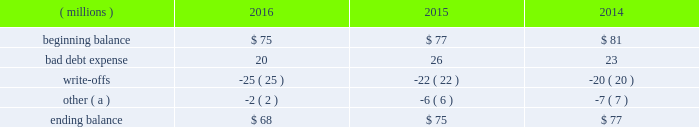Cash and cash equivalents cash equivalents include highly-liquid investments with a maturity of three months or less when purchased .
Accounts receivable and allowance for doubtful accounts accounts receivable are carried at the invoiced amounts , less an allowance for doubtful accounts , and generally do not bear interest .
The company estimates the balance of allowance for doubtful accounts by analyzing accounts receivable balances by age and applying historical write-off and collection trend rates .
The company 2019s estimates include separately providing for customer receivables based on specific circumstances and credit conditions , and when it is deemed probable that the balance is uncollectible .
Account balances are charged off against the allowance when it is determined the receivable will not be recovered .
The company 2019s allowance for doubtful accounts balance also includes an allowance for the expected return of products shipped and credits related to pricing or quantities shipped of $ 14 million , $ 15 million and $ 14 million as of december 31 , 2016 , 2015 , and 2014 , respectively .
Returns and credit activity is recorded directly to sales as a reduction .
The table summarizes the activity in the allowance for doubtful accounts: .
( a ) other amounts are primarily the effects of changes in currency translations and the impact of allowance for returns and credits .
Inventory valuations inventories are valued at the lower of cost or market .
Certain u.s .
Inventory costs are determined on a last-in , first-out ( 201clifo 201d ) basis .
Lifo inventories represented 40% ( 40 % ) and 39% ( 39 % ) of consolidated inventories as of december 31 , 2016 and 2015 , respectively .
Lifo inventories include certain legacy nalco u.s .
Inventory acquired at fair value as part of the nalco merger .
All other inventory costs are determined using either the average cost or first-in , first-out ( 201cfifo 201d ) methods .
Inventory values at fifo , as shown in note 5 , approximate replacement cost .
During 2015 , the company improved and standardized estimates related to its inventory reserves and product costing , resulting in a net pre-tax charge of approximately $ 6 million .
Separately , the actions resulted in a charge of $ 20.6 million related to inventory reserve calculations , partially offset by a gain of $ 14.5 million related to the capitalization of certain cost components into inventory .
During 2016 , the company took additional actions to improve and standardize estimates related to the capitalization of certain cost components into inventory , which resulted in a gain of $ 6.2 million .
These items are reflected within special ( gains ) and charges , as discussed in note 3 .
Property , plant and equipment property , plant and equipment assets are stated at cost .
Merchandising and customer equipment consists principally of various dispensing systems for the company 2019s cleaning and sanitizing products , dishwashing machines and process control and monitoring equipment .
Certain dispensing systems capitalized by the company are accounted for on a mass asset basis , whereby equipment is capitalized and depreciated as a group and written off when fully depreciated .
The company capitalizes both internal and external costs of development or purchase of computer software for internal use .
Costs incurred for data conversion , training and maintenance associated with capitalized software are expensed as incurred .
Expenditures for major renewals and improvements , which significantly extend the useful lives of existing plant and equipment , are capitalized and depreciated .
Expenditures for repairs and maintenance are charged to expense as incurred .
Upon retirement or disposition of plant and equipment , the cost and related accumulated depreciation are removed from the accounts and any resulting gain or loss is recognized in income .
Depreciation is charged to operations using the straight-line method over the assets 2019 estimated useful lives ranging from 5 to 40 years for buildings and leasehold improvements , 3 to 20 years for machinery and equipment , 3 to 15 years for merchandising and customer equipment and 3 to 7 years for capitalized software .
The straight-line method of depreciation reflects an appropriate allocation of the cost of the assets to earnings in proportion to the amount of economic benefits obtained by the company in each reporting period .
Depreciation expense was $ 561 million , $ 560 million and $ 558 million for 2016 , 2015 and 2014 , respectively. .
In millions , what was the average ending balance in allowance for doubtful accounts? 
Computations: table_average(ending balance, none)
Answer: 73.33333. 